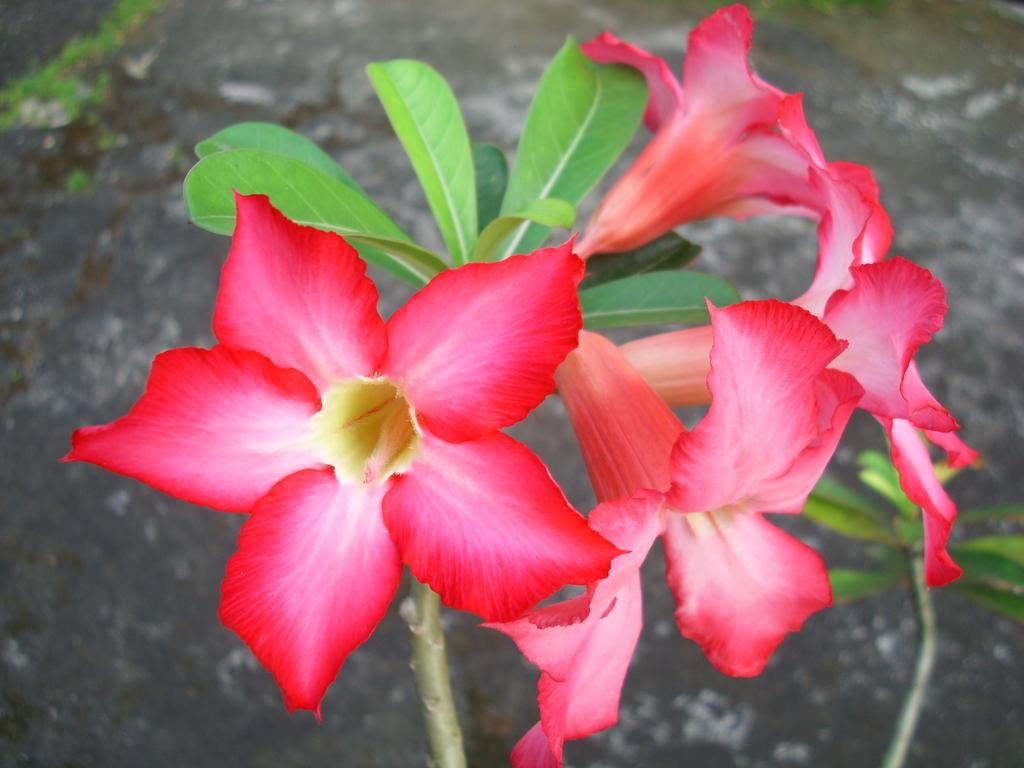What is in the foreground of the image? There are flowers in the foreground of the image. Where are the flowers located? The flowers are on a plant. What can be seen in the background of the image? In the background, there appears to be ground. Can you hear the animal making a quiet sound in the image? There is no animal present in the image, and therefore no sound can be heard. 